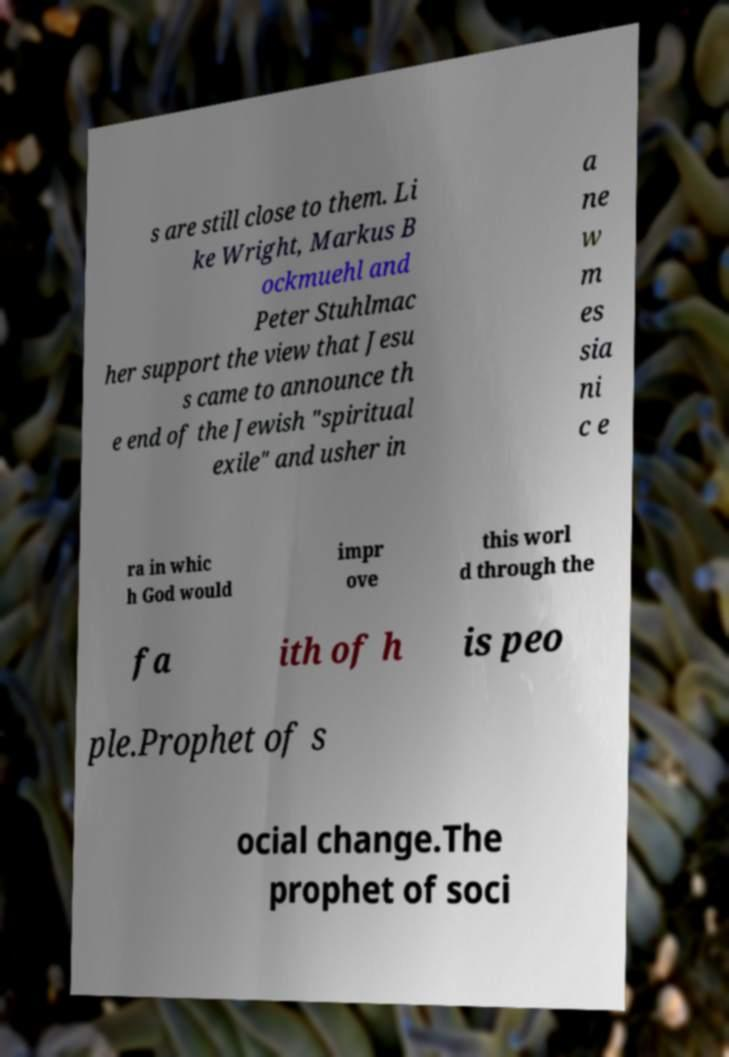Can you read and provide the text displayed in the image?This photo seems to have some interesting text. Can you extract and type it out for me? s are still close to them. Li ke Wright, Markus B ockmuehl and Peter Stuhlmac her support the view that Jesu s came to announce th e end of the Jewish "spiritual exile" and usher in a ne w m es sia ni c e ra in whic h God would impr ove this worl d through the fa ith of h is peo ple.Prophet of s ocial change.The prophet of soci 